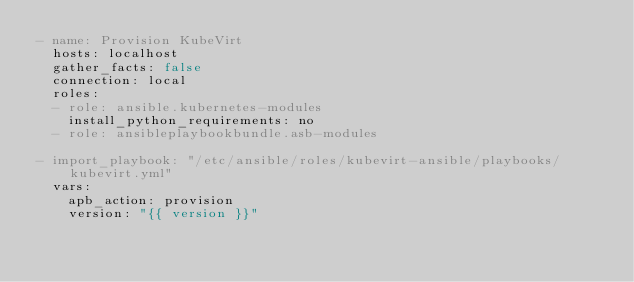Convert code to text. <code><loc_0><loc_0><loc_500><loc_500><_YAML_>- name: Provision KubeVirt
  hosts: localhost
  gather_facts: false
  connection: local
  roles:
  - role: ansible.kubernetes-modules
    install_python_requirements: no
  - role: ansibleplaybookbundle.asb-modules

- import_playbook: "/etc/ansible/roles/kubevirt-ansible/playbooks/kubevirt.yml"
  vars:
    apb_action: provision
    version: "{{ version }}"
</code> 